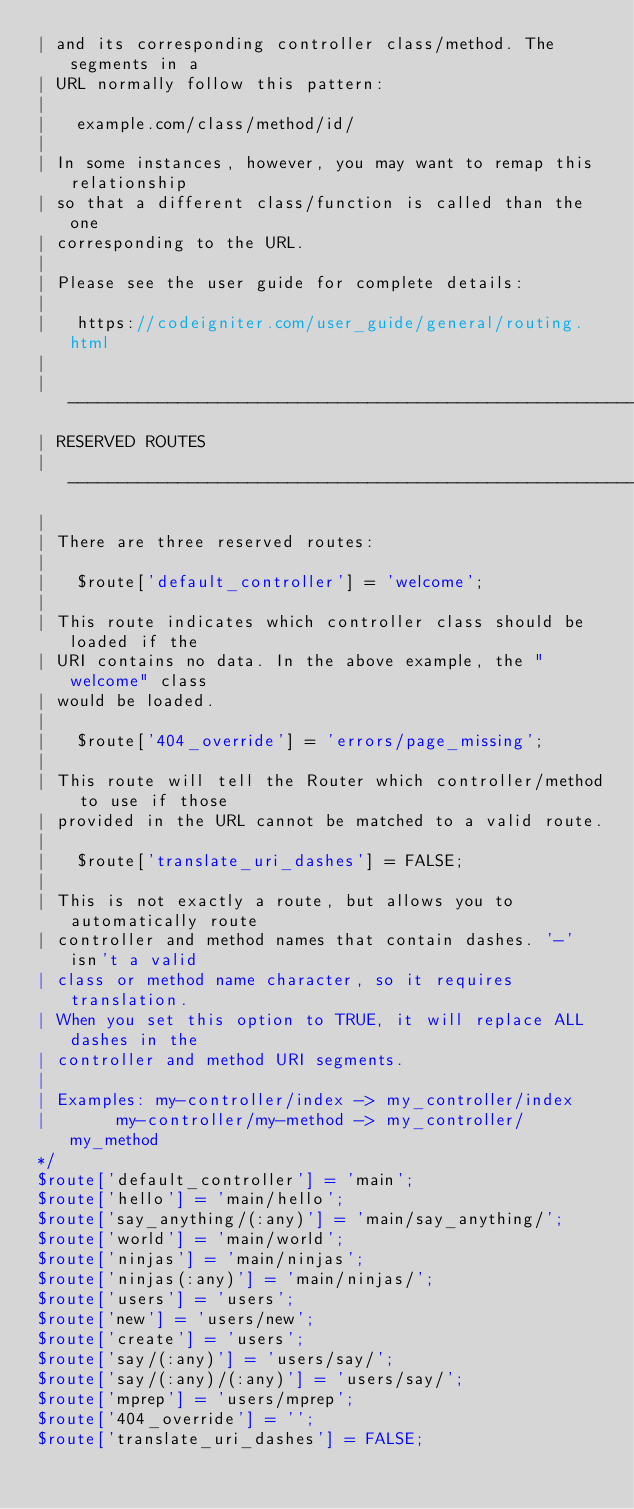Convert code to text. <code><loc_0><loc_0><loc_500><loc_500><_PHP_>| and its corresponding controller class/method. The segments in a
| URL normally follow this pattern:
|
|	example.com/class/method/id/
|
| In some instances, however, you may want to remap this relationship
| so that a different class/function is called than the one
| corresponding to the URL.
|
| Please see the user guide for complete details:
|
|	https://codeigniter.com/user_guide/general/routing.html
|
| -------------------------------------------------------------------------
| RESERVED ROUTES
| -------------------------------------------------------------------------
|
| There are three reserved routes:
|
|	$route['default_controller'] = 'welcome';
|
| This route indicates which controller class should be loaded if the
| URI contains no data. In the above example, the "welcome" class
| would be loaded.
|
|	$route['404_override'] = 'errors/page_missing';
|
| This route will tell the Router which controller/method to use if those
| provided in the URL cannot be matched to a valid route.
|
|	$route['translate_uri_dashes'] = FALSE;
|
| This is not exactly a route, but allows you to automatically route
| controller and method names that contain dashes. '-' isn't a valid
| class or method name character, so it requires translation.
| When you set this option to TRUE, it will replace ALL dashes in the
| controller and method URI segments.
|
| Examples:	my-controller/index	-> my_controller/index
|		my-controller/my-method	-> my_controller/my_method
*/
$route['default_controller'] = 'main';
$route['hello'] = 'main/hello';
$route['say_anything/(:any)'] = 'main/say_anything/';
$route['world'] = 'main/world';
$route['ninjas'] = 'main/ninjas';
$route['ninjas(:any)'] = 'main/ninjas/';
$route['users'] = 'users';
$route['new'] = 'users/new';
$route['create'] = 'users';
$route['say/(:any)'] = 'users/say/';
$route['say/(:any)/(:any)'] = 'users/say/';
$route['mprep'] = 'users/mprep';
$route['404_override'] = '';
$route['translate_uri_dashes'] = FALSE;
</code> 